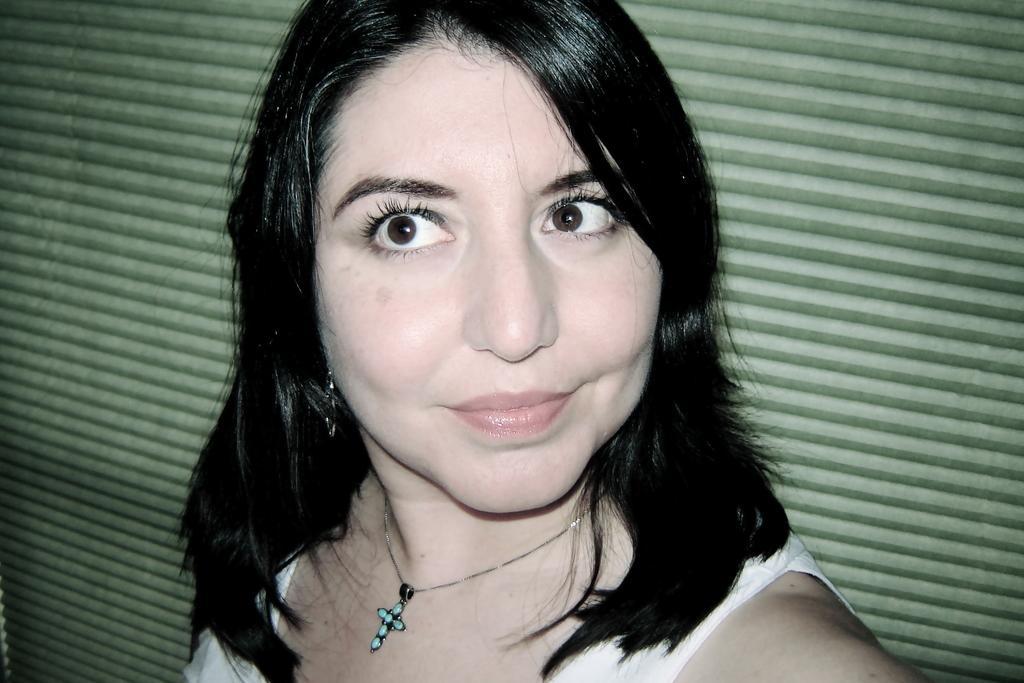Please provide a concise description of this image. In this image I can see a woman in the front and I can see she is wearing white colour dress and a locket on her neck. In the background I can see green colour shutter. 